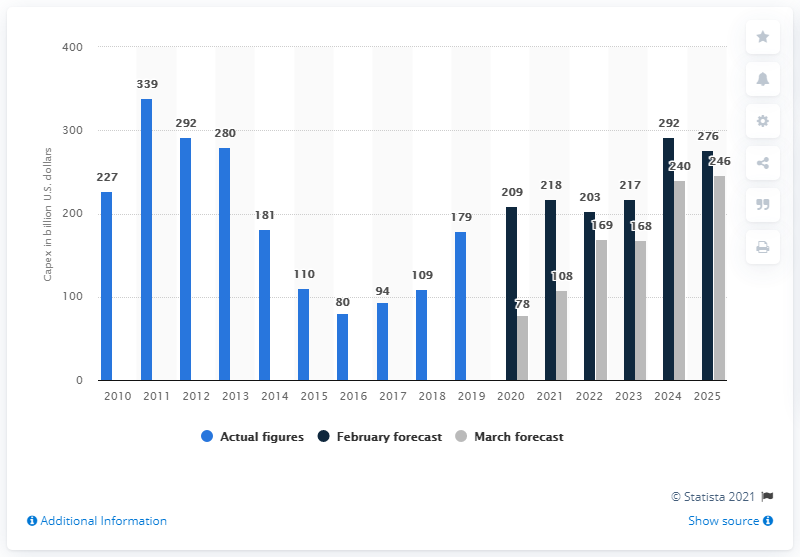List a handful of essential elements in this visual. According to projections, the capital expenditure for conventional oil and gas fields worldwide is expected to decrease significantly from $78 billion in 2020 to a much lower amount in US dollars. The value of projects expected to reach final investment decision was estimated to be approximately $209 million. 